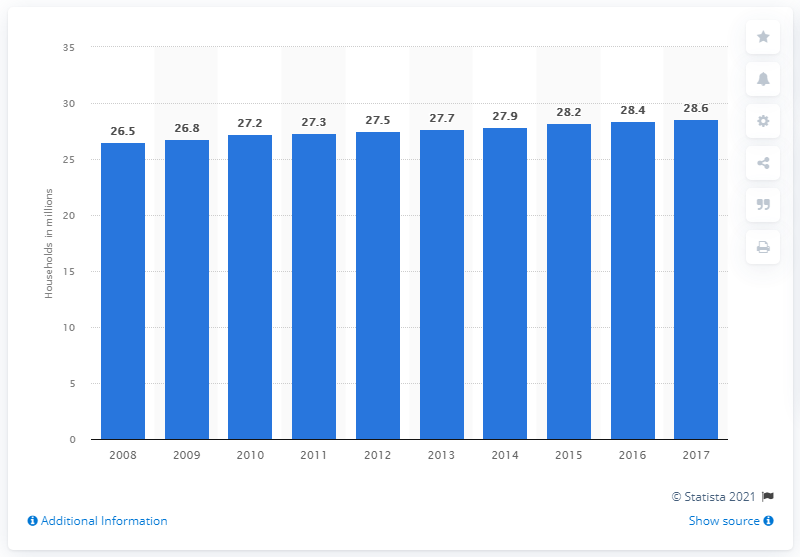Point out several critical features in this image. In 2017, approximately 28.6% of French households owned at least one television. In 2008, it was reported that approximately 26.5% of households in France disposed of at least one television. 